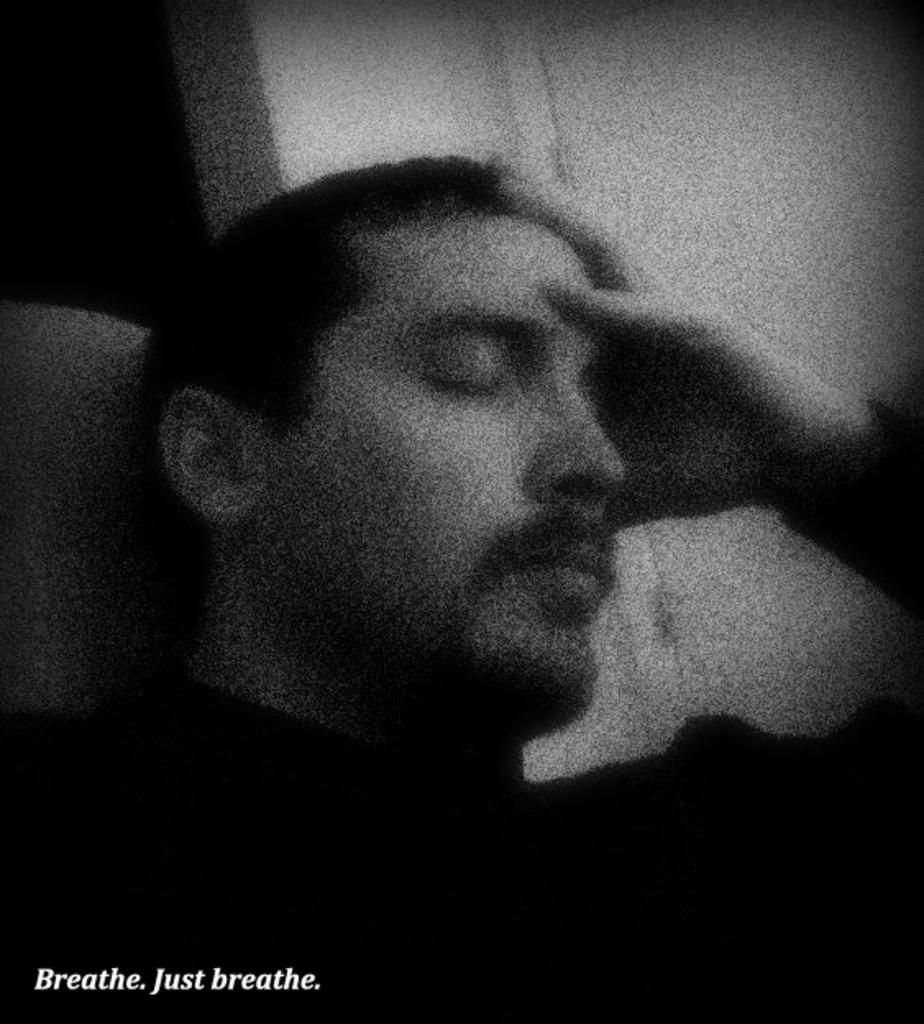What is the main subject of the image? There is a person in the middle of the image. What is the color scheme of the image? The image is in black and white. Where is the text located in the image? The text is in the bottom left corner of the image. What type of impulse can be seen affecting the person in the image? There is no impulse visible in the image; it only shows a person in a black and white setting with text in the bottom left corner. 